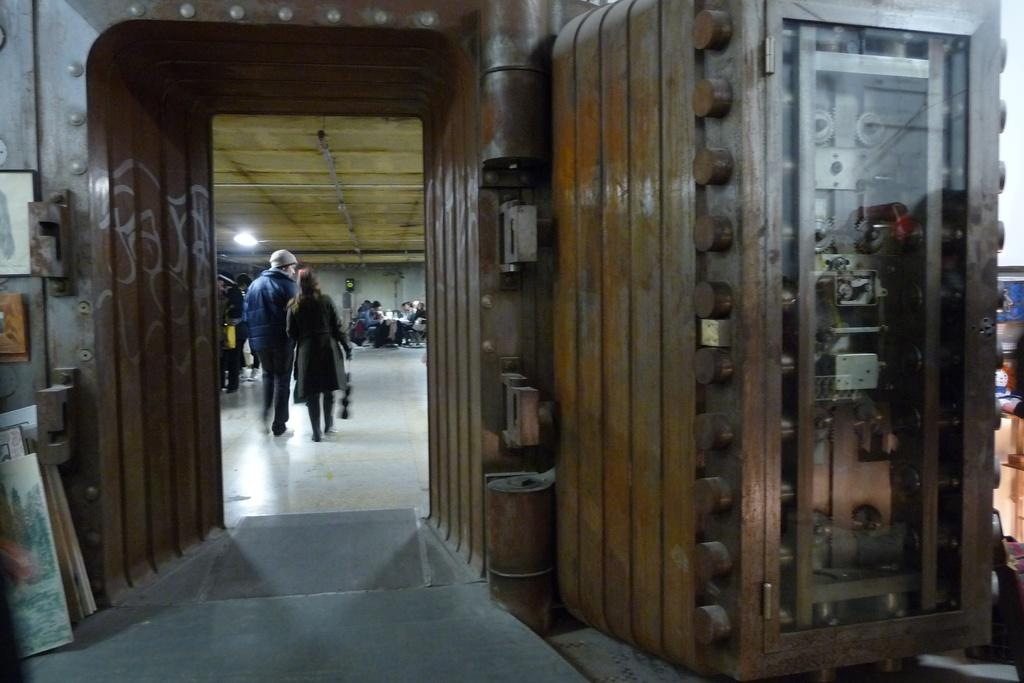Who can be seen in the image? There is a man and a woman in the image. What are the man and woman doing in the image? The man and woman are walking. What is visible at the top of the image? There is a light at the top of the image. What type of can is being used by the man and woman in the image? There is no can present in the image; the man and woman are walking. What is the cause of the war depicted in the image? There is no war depicted in the image; it features a man and a woman walking. 